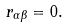<formula> <loc_0><loc_0><loc_500><loc_500>r _ { \alpha \beta } = 0 .</formula> 